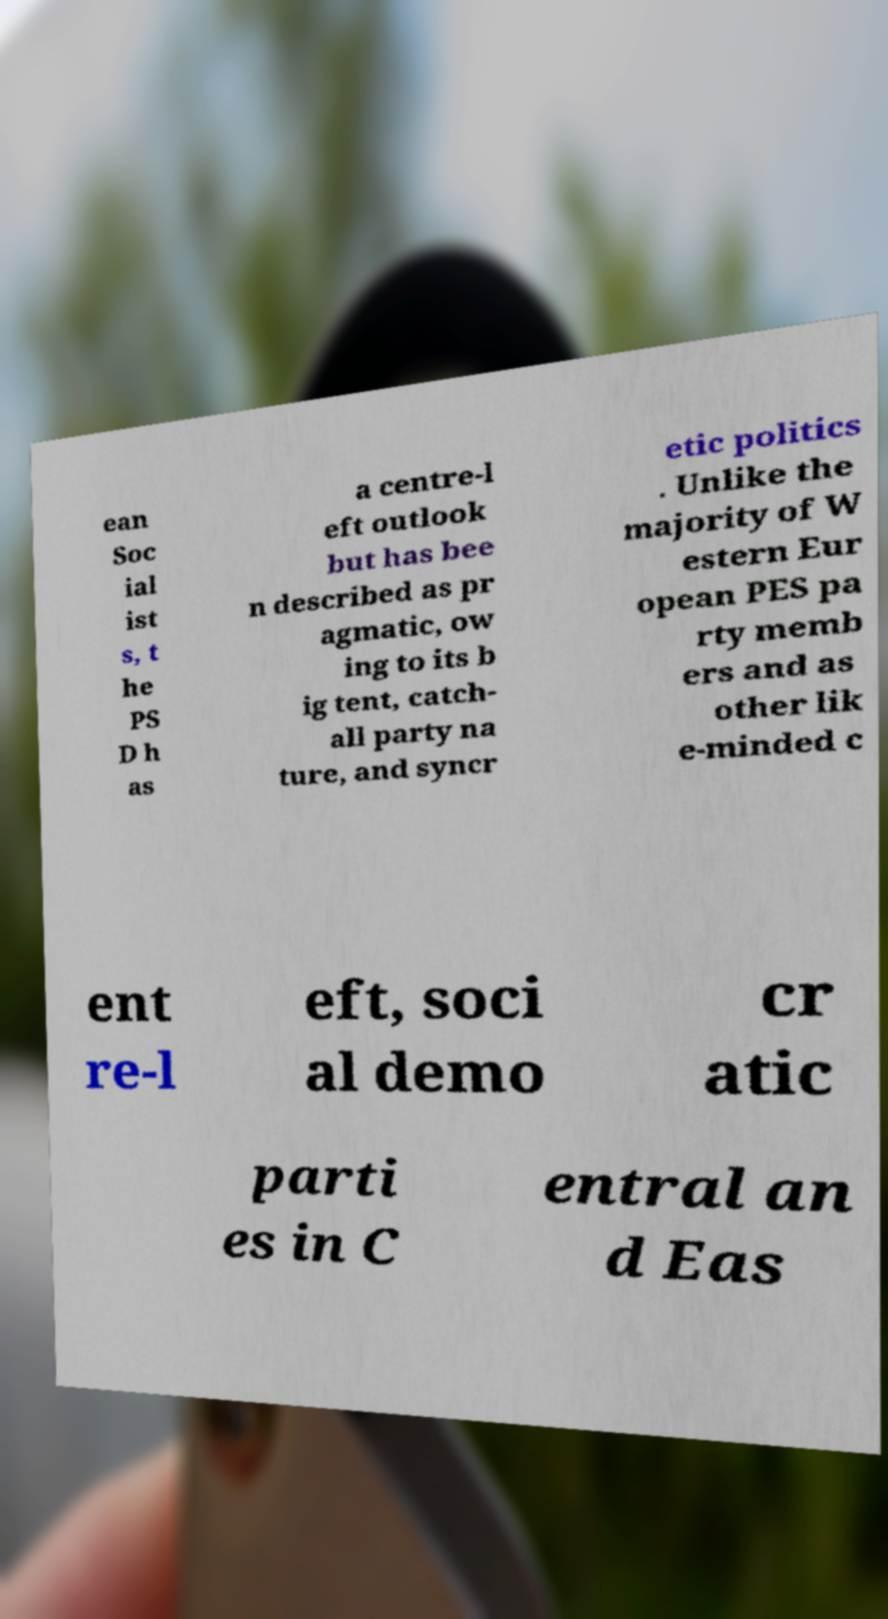Can you read and provide the text displayed in the image?This photo seems to have some interesting text. Can you extract and type it out for me? ean Soc ial ist s, t he PS D h as a centre-l eft outlook but has bee n described as pr agmatic, ow ing to its b ig tent, catch- all party na ture, and syncr etic politics . Unlike the majority of W estern Eur opean PES pa rty memb ers and as other lik e-minded c ent re-l eft, soci al demo cr atic parti es in C entral an d Eas 